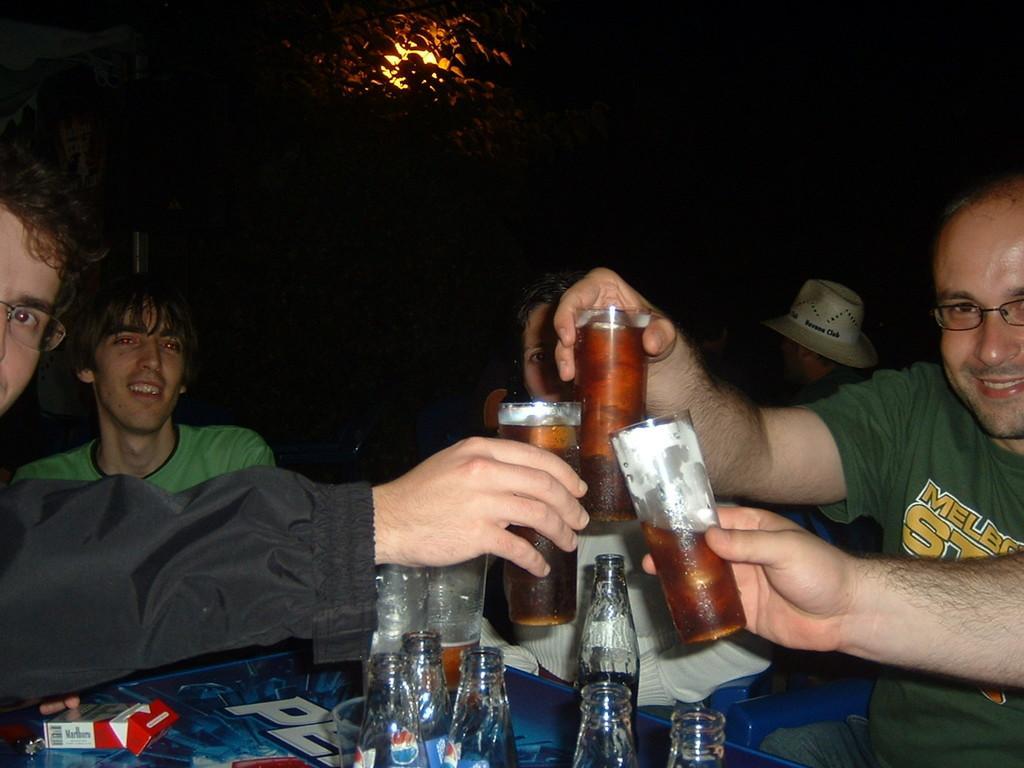Please provide a concise description of this image. In this image there are 2 persons sitting in the chair ,another 2 persons sitting in the chair holding a glass of drink in their hands and a table with 6 bottles and a cigarette packet. 